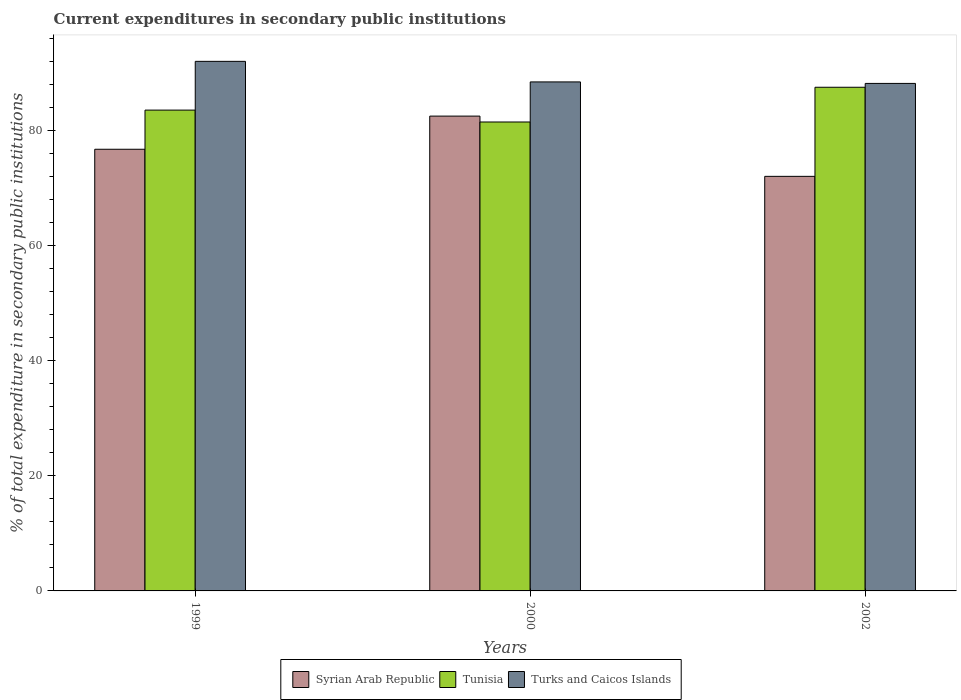How many groups of bars are there?
Give a very brief answer. 3. Are the number of bars on each tick of the X-axis equal?
Make the answer very short. Yes. How many bars are there on the 2nd tick from the left?
Offer a very short reply. 3. What is the current expenditures in secondary public institutions in Syrian Arab Republic in 1999?
Offer a very short reply. 76.79. Across all years, what is the maximum current expenditures in secondary public institutions in Tunisia?
Offer a terse response. 87.57. Across all years, what is the minimum current expenditures in secondary public institutions in Turks and Caicos Islands?
Offer a very short reply. 88.24. In which year was the current expenditures in secondary public institutions in Turks and Caicos Islands minimum?
Your answer should be compact. 2002. What is the total current expenditures in secondary public institutions in Tunisia in the graph?
Make the answer very short. 252.71. What is the difference between the current expenditures in secondary public institutions in Syrian Arab Republic in 1999 and that in 2002?
Ensure brevity in your answer.  4.71. What is the difference between the current expenditures in secondary public institutions in Turks and Caicos Islands in 2000 and the current expenditures in secondary public institutions in Syrian Arab Republic in 2002?
Keep it short and to the point. 16.42. What is the average current expenditures in secondary public institutions in Syrian Arab Republic per year?
Provide a succinct answer. 77.14. In the year 2000, what is the difference between the current expenditures in secondary public institutions in Turks and Caicos Islands and current expenditures in secondary public institutions in Syrian Arab Republic?
Make the answer very short. 5.95. What is the ratio of the current expenditures in secondary public institutions in Syrian Arab Republic in 1999 to that in 2002?
Keep it short and to the point. 1.07. Is the current expenditures in secondary public institutions in Turks and Caicos Islands in 2000 less than that in 2002?
Provide a succinct answer. No. Is the difference between the current expenditures in secondary public institutions in Turks and Caicos Islands in 1999 and 2000 greater than the difference between the current expenditures in secondary public institutions in Syrian Arab Republic in 1999 and 2000?
Your response must be concise. Yes. What is the difference between the highest and the second highest current expenditures in secondary public institutions in Syrian Arab Republic?
Make the answer very short. 5.76. What is the difference between the highest and the lowest current expenditures in secondary public institutions in Syrian Arab Republic?
Provide a short and direct response. 10.48. Is the sum of the current expenditures in secondary public institutions in Turks and Caicos Islands in 1999 and 2000 greater than the maximum current expenditures in secondary public institutions in Tunisia across all years?
Your answer should be very brief. Yes. What does the 2nd bar from the left in 2000 represents?
Keep it short and to the point. Tunisia. What does the 3rd bar from the right in 2002 represents?
Provide a short and direct response. Syrian Arab Republic. How many legend labels are there?
Offer a very short reply. 3. How are the legend labels stacked?
Your response must be concise. Horizontal. What is the title of the graph?
Ensure brevity in your answer.  Current expenditures in secondary public institutions. What is the label or title of the Y-axis?
Make the answer very short. % of total expenditure in secondary public institutions. What is the % of total expenditure in secondary public institutions of Syrian Arab Republic in 1999?
Make the answer very short. 76.79. What is the % of total expenditure in secondary public institutions of Tunisia in 1999?
Your answer should be compact. 83.6. What is the % of total expenditure in secondary public institutions in Turks and Caicos Islands in 1999?
Offer a very short reply. 92.08. What is the % of total expenditure in secondary public institutions in Syrian Arab Republic in 2000?
Your answer should be compact. 82.56. What is the % of total expenditure in secondary public institutions of Tunisia in 2000?
Provide a short and direct response. 81.53. What is the % of total expenditure in secondary public institutions in Turks and Caicos Islands in 2000?
Your response must be concise. 88.5. What is the % of total expenditure in secondary public institutions of Syrian Arab Republic in 2002?
Ensure brevity in your answer.  72.08. What is the % of total expenditure in secondary public institutions in Tunisia in 2002?
Your answer should be very brief. 87.57. What is the % of total expenditure in secondary public institutions in Turks and Caicos Islands in 2002?
Keep it short and to the point. 88.24. Across all years, what is the maximum % of total expenditure in secondary public institutions of Syrian Arab Republic?
Give a very brief answer. 82.56. Across all years, what is the maximum % of total expenditure in secondary public institutions in Tunisia?
Your answer should be compact. 87.57. Across all years, what is the maximum % of total expenditure in secondary public institutions in Turks and Caicos Islands?
Provide a succinct answer. 92.08. Across all years, what is the minimum % of total expenditure in secondary public institutions in Syrian Arab Republic?
Offer a terse response. 72.08. Across all years, what is the minimum % of total expenditure in secondary public institutions in Tunisia?
Give a very brief answer. 81.53. Across all years, what is the minimum % of total expenditure in secondary public institutions of Turks and Caicos Islands?
Your answer should be very brief. 88.24. What is the total % of total expenditure in secondary public institutions of Syrian Arab Republic in the graph?
Your answer should be compact. 231.43. What is the total % of total expenditure in secondary public institutions in Tunisia in the graph?
Offer a very short reply. 252.71. What is the total % of total expenditure in secondary public institutions of Turks and Caicos Islands in the graph?
Your response must be concise. 268.82. What is the difference between the % of total expenditure in secondary public institutions of Syrian Arab Republic in 1999 and that in 2000?
Your response must be concise. -5.76. What is the difference between the % of total expenditure in secondary public institutions of Tunisia in 1999 and that in 2000?
Provide a succinct answer. 2.07. What is the difference between the % of total expenditure in secondary public institutions in Turks and Caicos Islands in 1999 and that in 2000?
Keep it short and to the point. 3.57. What is the difference between the % of total expenditure in secondary public institutions of Syrian Arab Republic in 1999 and that in 2002?
Keep it short and to the point. 4.71. What is the difference between the % of total expenditure in secondary public institutions of Tunisia in 1999 and that in 2002?
Offer a very short reply. -3.97. What is the difference between the % of total expenditure in secondary public institutions of Turks and Caicos Islands in 1999 and that in 2002?
Ensure brevity in your answer.  3.83. What is the difference between the % of total expenditure in secondary public institutions in Syrian Arab Republic in 2000 and that in 2002?
Offer a terse response. 10.48. What is the difference between the % of total expenditure in secondary public institutions of Tunisia in 2000 and that in 2002?
Give a very brief answer. -6.04. What is the difference between the % of total expenditure in secondary public institutions in Turks and Caicos Islands in 2000 and that in 2002?
Your answer should be compact. 0.26. What is the difference between the % of total expenditure in secondary public institutions of Syrian Arab Republic in 1999 and the % of total expenditure in secondary public institutions of Tunisia in 2000?
Keep it short and to the point. -4.74. What is the difference between the % of total expenditure in secondary public institutions of Syrian Arab Republic in 1999 and the % of total expenditure in secondary public institutions of Turks and Caicos Islands in 2000?
Provide a short and direct response. -11.71. What is the difference between the % of total expenditure in secondary public institutions of Tunisia in 1999 and the % of total expenditure in secondary public institutions of Turks and Caicos Islands in 2000?
Provide a short and direct response. -4.9. What is the difference between the % of total expenditure in secondary public institutions in Syrian Arab Republic in 1999 and the % of total expenditure in secondary public institutions in Tunisia in 2002?
Your answer should be very brief. -10.78. What is the difference between the % of total expenditure in secondary public institutions of Syrian Arab Republic in 1999 and the % of total expenditure in secondary public institutions of Turks and Caicos Islands in 2002?
Your response must be concise. -11.45. What is the difference between the % of total expenditure in secondary public institutions of Tunisia in 1999 and the % of total expenditure in secondary public institutions of Turks and Caicos Islands in 2002?
Keep it short and to the point. -4.64. What is the difference between the % of total expenditure in secondary public institutions in Syrian Arab Republic in 2000 and the % of total expenditure in secondary public institutions in Tunisia in 2002?
Offer a terse response. -5.02. What is the difference between the % of total expenditure in secondary public institutions of Syrian Arab Republic in 2000 and the % of total expenditure in secondary public institutions of Turks and Caicos Islands in 2002?
Give a very brief answer. -5.69. What is the difference between the % of total expenditure in secondary public institutions in Tunisia in 2000 and the % of total expenditure in secondary public institutions in Turks and Caicos Islands in 2002?
Keep it short and to the point. -6.71. What is the average % of total expenditure in secondary public institutions of Syrian Arab Republic per year?
Make the answer very short. 77.14. What is the average % of total expenditure in secondary public institutions of Tunisia per year?
Your response must be concise. 84.24. What is the average % of total expenditure in secondary public institutions of Turks and Caicos Islands per year?
Give a very brief answer. 89.61. In the year 1999, what is the difference between the % of total expenditure in secondary public institutions in Syrian Arab Republic and % of total expenditure in secondary public institutions in Tunisia?
Offer a terse response. -6.81. In the year 1999, what is the difference between the % of total expenditure in secondary public institutions in Syrian Arab Republic and % of total expenditure in secondary public institutions in Turks and Caicos Islands?
Offer a terse response. -15.28. In the year 1999, what is the difference between the % of total expenditure in secondary public institutions in Tunisia and % of total expenditure in secondary public institutions in Turks and Caicos Islands?
Your response must be concise. -8.48. In the year 2000, what is the difference between the % of total expenditure in secondary public institutions of Syrian Arab Republic and % of total expenditure in secondary public institutions of Tunisia?
Give a very brief answer. 1.02. In the year 2000, what is the difference between the % of total expenditure in secondary public institutions of Syrian Arab Republic and % of total expenditure in secondary public institutions of Turks and Caicos Islands?
Your answer should be compact. -5.95. In the year 2000, what is the difference between the % of total expenditure in secondary public institutions in Tunisia and % of total expenditure in secondary public institutions in Turks and Caicos Islands?
Keep it short and to the point. -6.97. In the year 2002, what is the difference between the % of total expenditure in secondary public institutions of Syrian Arab Republic and % of total expenditure in secondary public institutions of Tunisia?
Offer a very short reply. -15.49. In the year 2002, what is the difference between the % of total expenditure in secondary public institutions of Syrian Arab Republic and % of total expenditure in secondary public institutions of Turks and Caicos Islands?
Your response must be concise. -16.16. In the year 2002, what is the difference between the % of total expenditure in secondary public institutions of Tunisia and % of total expenditure in secondary public institutions of Turks and Caicos Islands?
Make the answer very short. -0.67. What is the ratio of the % of total expenditure in secondary public institutions in Syrian Arab Republic in 1999 to that in 2000?
Your response must be concise. 0.93. What is the ratio of the % of total expenditure in secondary public institutions of Tunisia in 1999 to that in 2000?
Offer a very short reply. 1.03. What is the ratio of the % of total expenditure in secondary public institutions of Turks and Caicos Islands in 1999 to that in 2000?
Your response must be concise. 1.04. What is the ratio of the % of total expenditure in secondary public institutions of Syrian Arab Republic in 1999 to that in 2002?
Provide a succinct answer. 1.07. What is the ratio of the % of total expenditure in secondary public institutions of Tunisia in 1999 to that in 2002?
Ensure brevity in your answer.  0.95. What is the ratio of the % of total expenditure in secondary public institutions of Turks and Caicos Islands in 1999 to that in 2002?
Keep it short and to the point. 1.04. What is the ratio of the % of total expenditure in secondary public institutions in Syrian Arab Republic in 2000 to that in 2002?
Offer a terse response. 1.15. What is the difference between the highest and the second highest % of total expenditure in secondary public institutions in Syrian Arab Republic?
Provide a succinct answer. 5.76. What is the difference between the highest and the second highest % of total expenditure in secondary public institutions of Tunisia?
Ensure brevity in your answer.  3.97. What is the difference between the highest and the second highest % of total expenditure in secondary public institutions of Turks and Caicos Islands?
Give a very brief answer. 3.57. What is the difference between the highest and the lowest % of total expenditure in secondary public institutions in Syrian Arab Republic?
Provide a succinct answer. 10.48. What is the difference between the highest and the lowest % of total expenditure in secondary public institutions in Tunisia?
Your answer should be very brief. 6.04. What is the difference between the highest and the lowest % of total expenditure in secondary public institutions of Turks and Caicos Islands?
Your response must be concise. 3.83. 